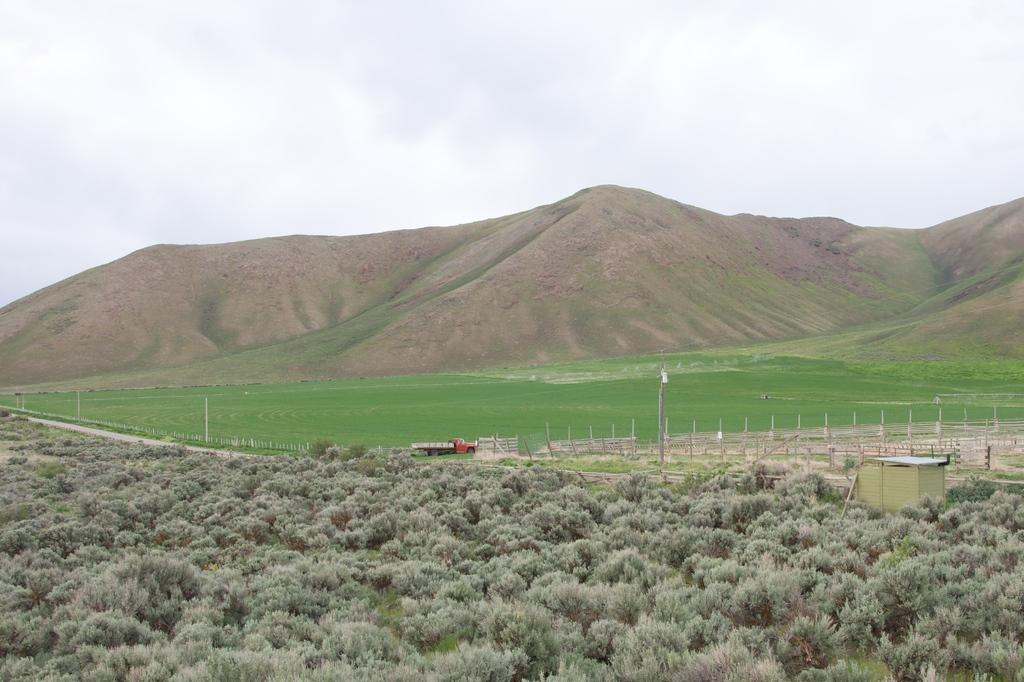What is moving in the image? There is a truck moving in the image. What type of vegetation can be seen in the image? There is grass, plants, and trees in the image. What is visible in the background of the image? There is a mountain in the background of the image. What is the condition of the sky in the image? The sky is clear in the image. How many masses can be seen in the image? There is no mass present in the image. 